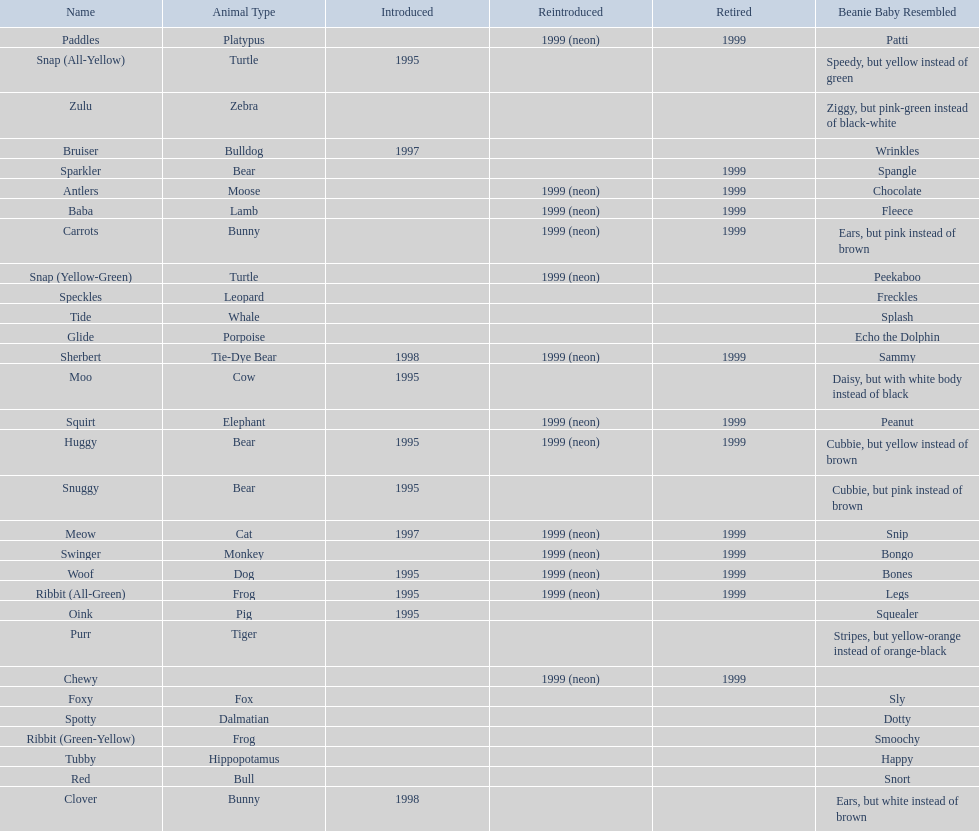Which is the only pillow pal without a listed animal type? Chewy. 